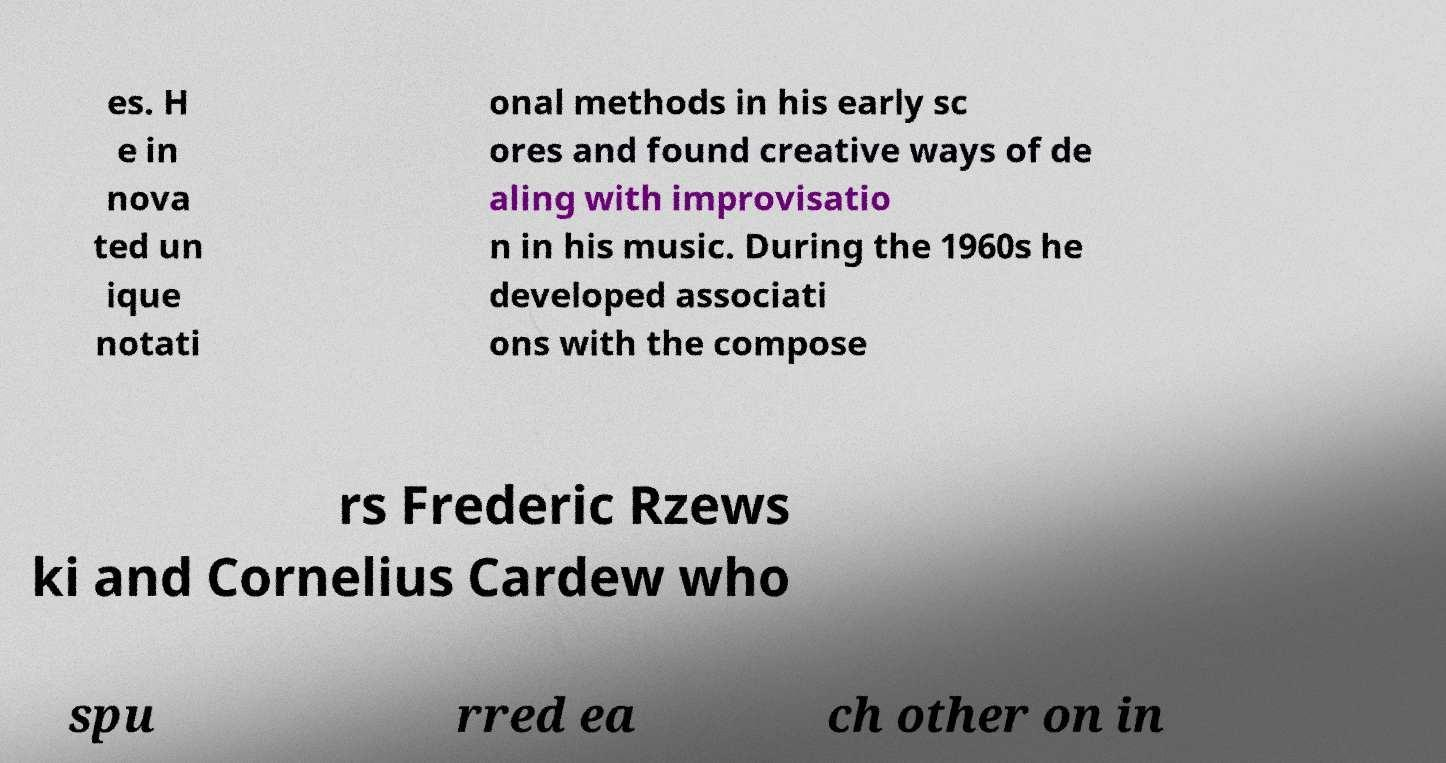Can you read and provide the text displayed in the image?This photo seems to have some interesting text. Can you extract and type it out for me? es. H e in nova ted un ique notati onal methods in his early sc ores and found creative ways of de aling with improvisatio n in his music. During the 1960s he developed associati ons with the compose rs Frederic Rzews ki and Cornelius Cardew who spu rred ea ch other on in 